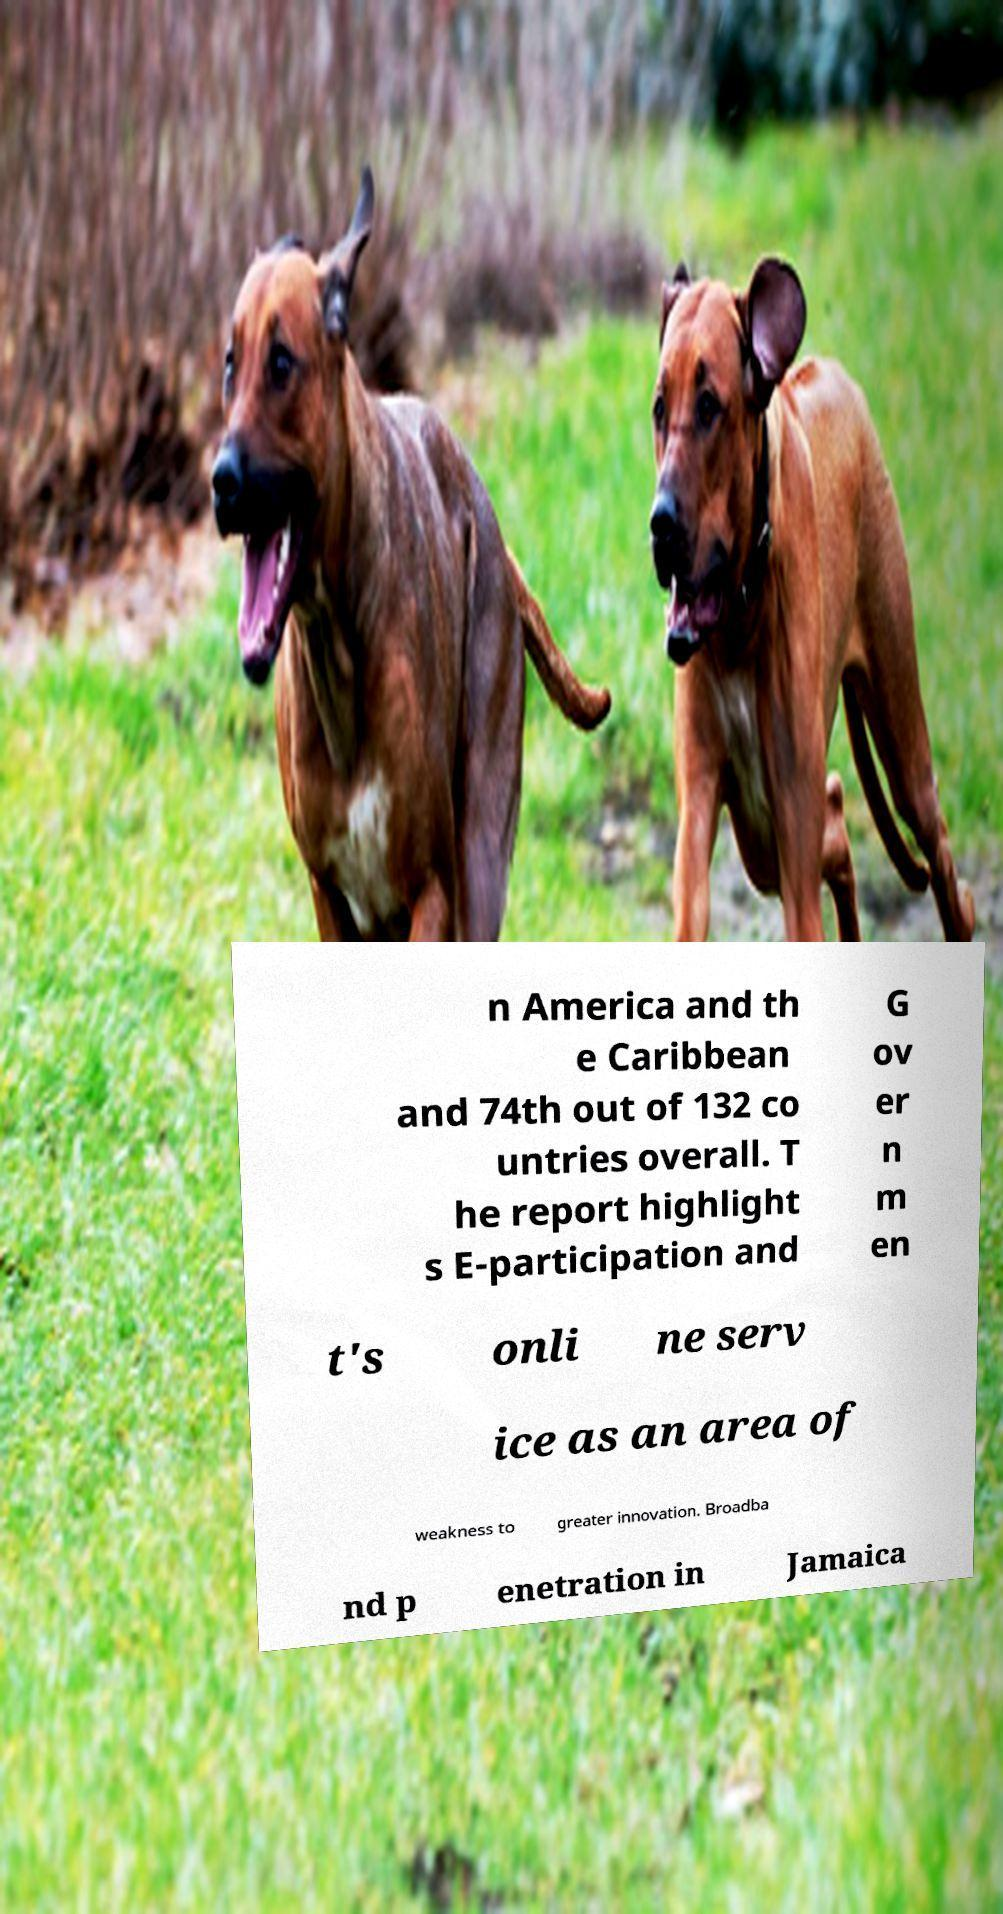Please identify and transcribe the text found in this image. n America and th e Caribbean and 74th out of 132 co untries overall. T he report highlight s E-participation and G ov er n m en t's onli ne serv ice as an area of weakness to greater innovation. Broadba nd p enetration in Jamaica 